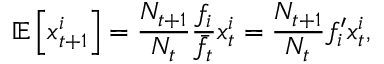Convert formula to latex. <formula><loc_0><loc_0><loc_500><loc_500>\mathbb { E } \left [ x _ { t + 1 } ^ { i } \right ] = \frac { N _ { t + 1 } } { N _ { t } } \frac { f _ { i } } { \bar { f } _ { t } } x _ { t } ^ { i } = \frac { N _ { t + 1 } } { N _ { t } } f _ { i } ^ { \prime } x _ { t } ^ { i } ,</formula> 